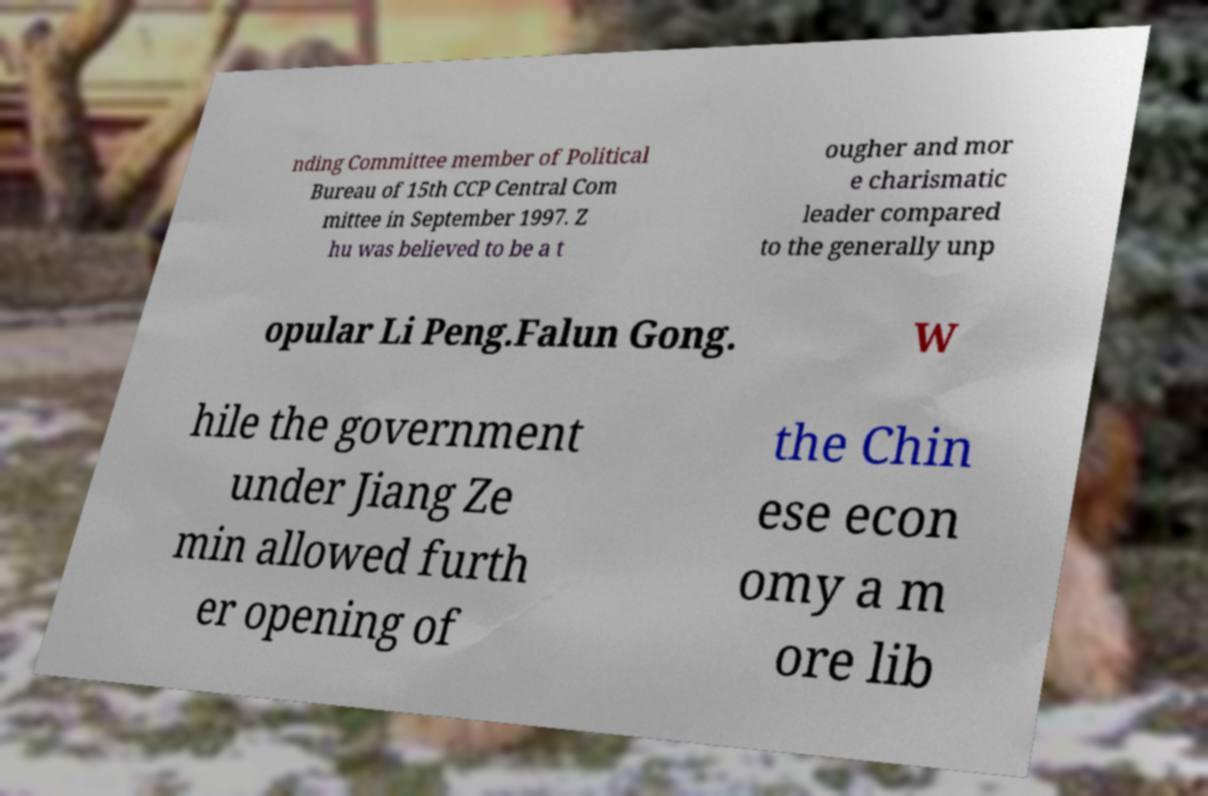There's text embedded in this image that I need extracted. Can you transcribe it verbatim? nding Committee member of Political Bureau of 15th CCP Central Com mittee in September 1997. Z hu was believed to be a t ougher and mor e charismatic leader compared to the generally unp opular Li Peng.Falun Gong. W hile the government under Jiang Ze min allowed furth er opening of the Chin ese econ omy a m ore lib 